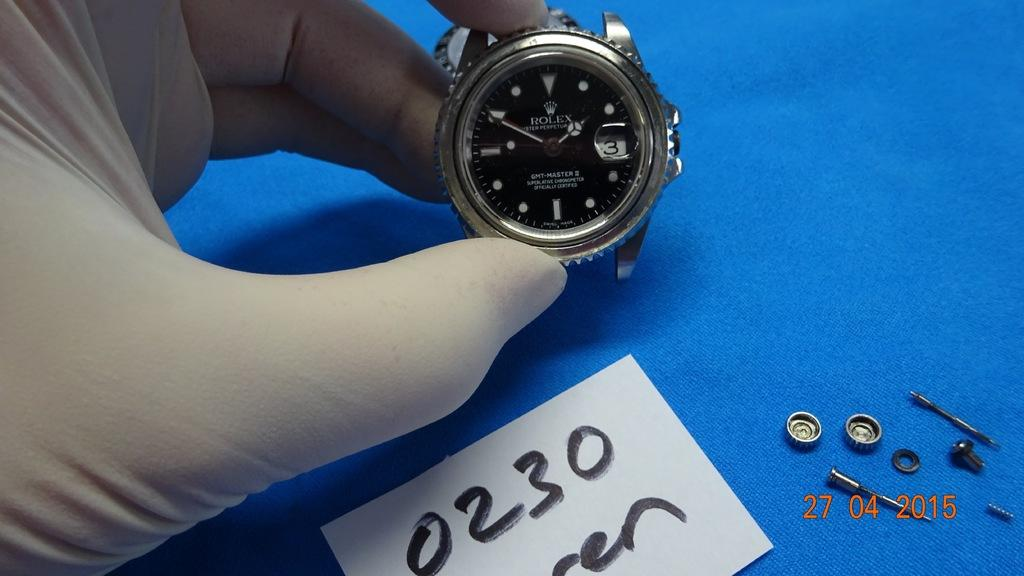<image>
Present a compact description of the photo's key features. A person holds a watch with their left hand and it shows a time of 1:50. 